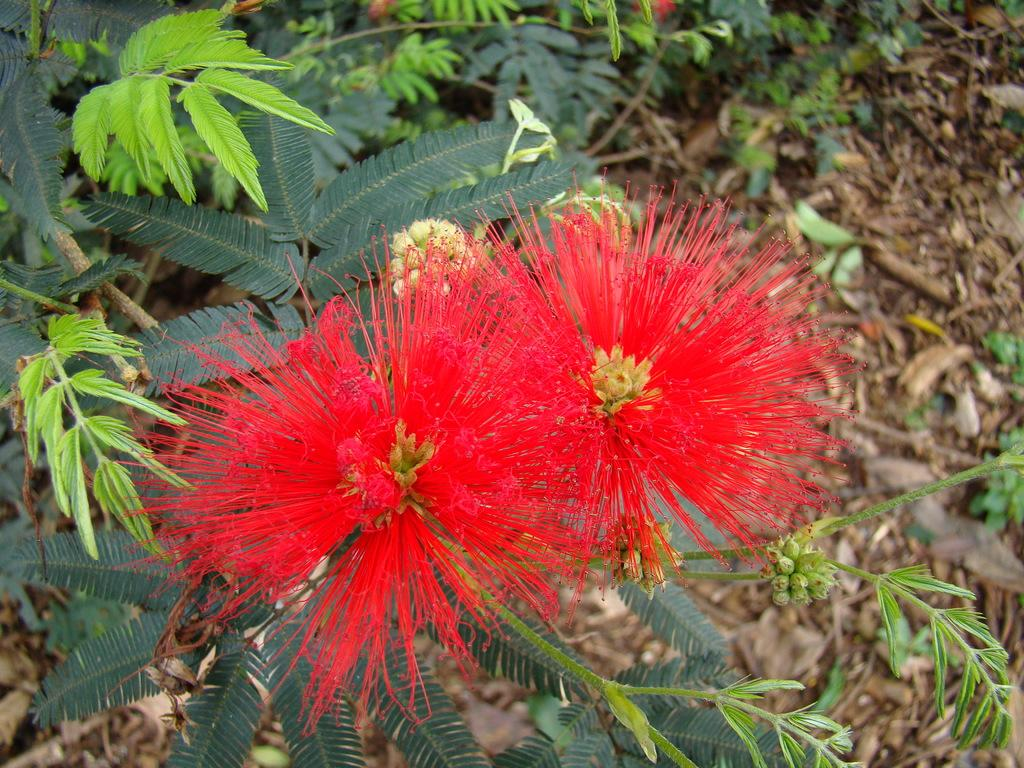What type of living organisms can be seen in the image? Plants can be seen in the image. What specific features are present on the plants? The plants have flowers and leaves. What type of jelly can be seen on the leaves of the plants in the image? There is no jelly present on the leaves of the plants in the image. 